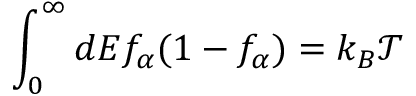<formula> <loc_0><loc_0><loc_500><loc_500>\int _ { 0 } ^ { \infty } d E f _ { \alpha } ( 1 - f _ { \alpha } ) = k _ { B } \mathcal { T }</formula> 